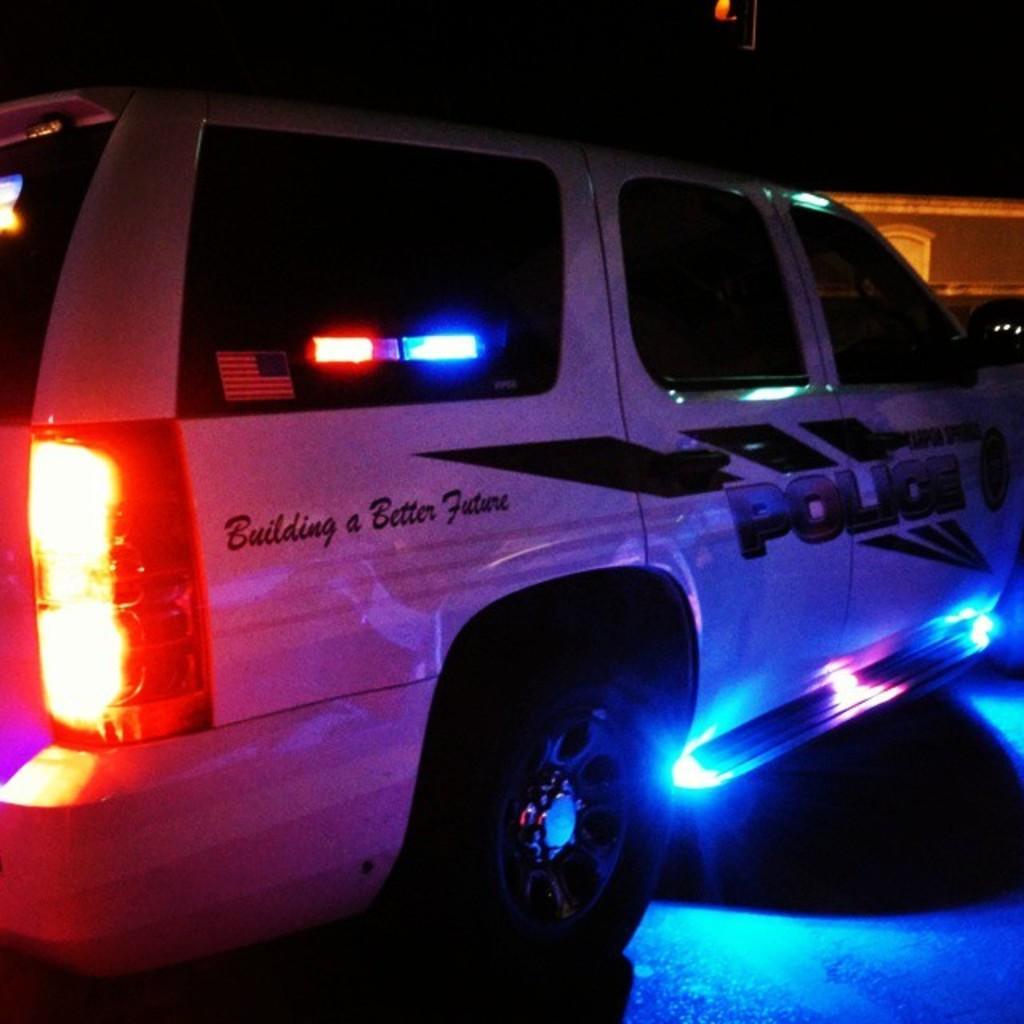How would you summarize this image in a sentence or two? There is a vehicle with lights. On that something is written. In the background it is dark. 